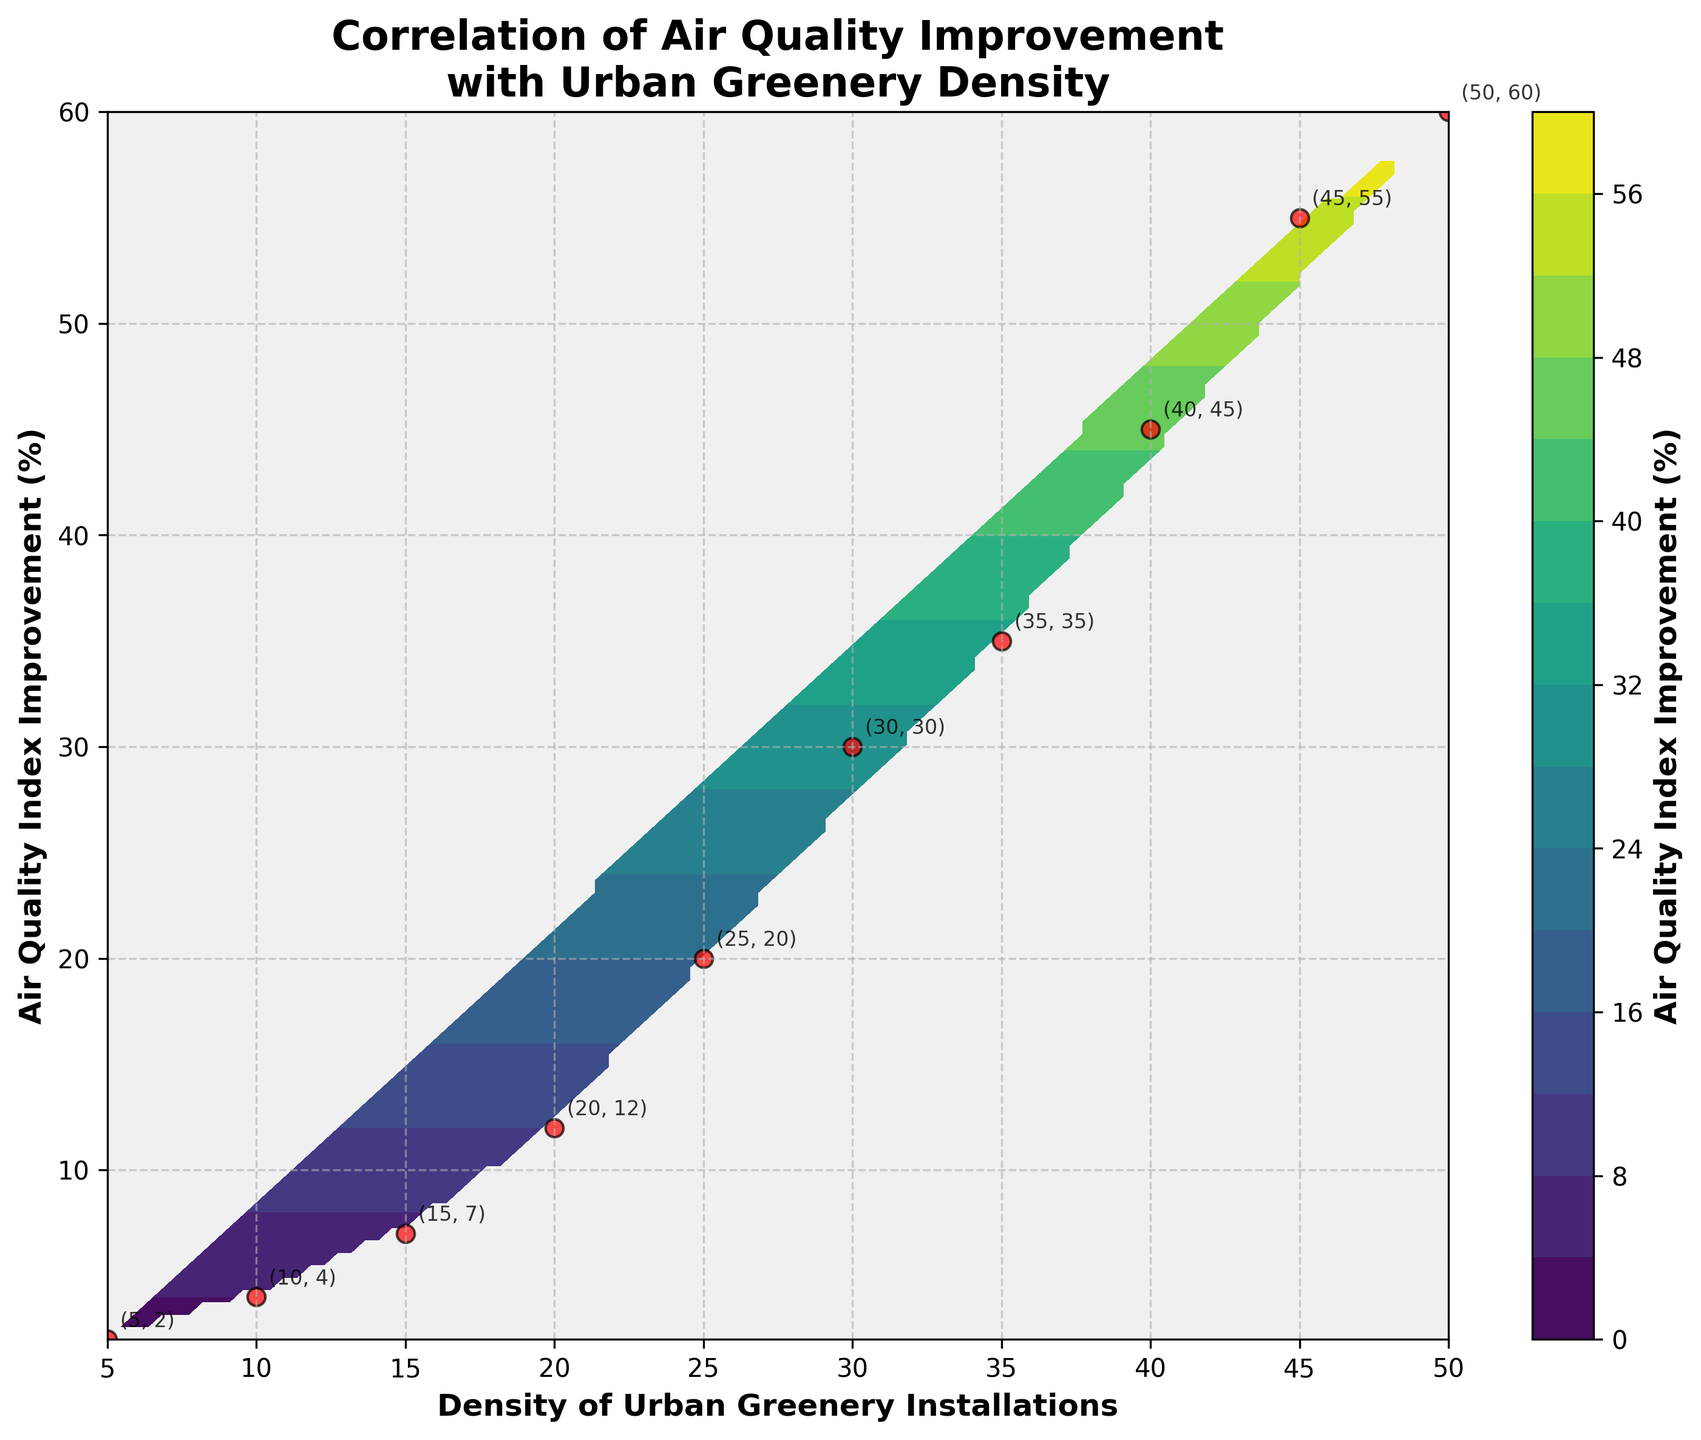What is the title of the figure? The title is usually found at the top of the figure. In this case, it states "Correlation of Air Quality Improvement with Urban Greenery Density".
Answer: Correlation of Air Quality Improvement with Urban Greenery Density What color represents the highest Air Quality Index Improvement percentage on the contour plot? The contour plot uses a colormap that varies in color intensity. The highest values are generally represented by the most intense color, which in this case is likely at the end of the 'viridis' color map.
Answer: Dark purple How does the Air Quality Index Improvement percentage change as the density of urban greenery installations increases from 5 to 50? The Air Quality Index Improvement percentage increases as the density of urban greenery installations increases. Specifically, it starts at 2% for a density of 5 and reaches 60% at a density of 50.
Answer: It increases Which data point corresponds to the highest Air Quality Index Improvement in the figure? The data point with the highest Air Quality Index Improvement can be identified by looking for the highest y-value in the scatter plot. The highest value happens at (50, 60).
Answer: (50, 60) How many contour levels are there in the plot? Contour levels are the number of divisions or lines in the contour plot. The code specifies 15 levels, but a visual count can confirm this.
Answer: 15 What is the label of the color bar in the figure? The label on the color bar can be found next to it and describes what the color represents in terms of data. In this case, it's 'Air Quality Index Improvement (%)'.
Answer: Air Quality Index Improvement (%) Compare the Air Quality Index Improvement percentage at densities of 10 and 35. What can you infer? The Air Quality Index Improvement percentage at a density of 10 is 4%, and at 35, it's 35%. Thus, it significantly increases as the density rises from 10 to 35.
Answer: It increases significantly What is the approximate Air Quality Index Improvement percentage at a density of 25 based on the contour plot? By locating the contour line that intersects a density of 25, we can approximate the Air Quality Index Improvement percentage. It seems to be around 20%.
Answer: 20% Is there any annotation for a data point with a density of 20? If yes, what is it? The annotations are text identifiers next to the data points. For the density of 20, the annotation can be seen as '(20, 12)'.
Answer: (20, 12) What trends or patterns can you observe from the contour plot regarding the relationship between urban greenery density and air quality improvement? Observing the contour lines, we see an upward trend indicating that as the density of urban greenery installations increases, there is a noticeable improvement in the Air Quality Index, suggesting a positive correlation.
Answer: Positive correlation 